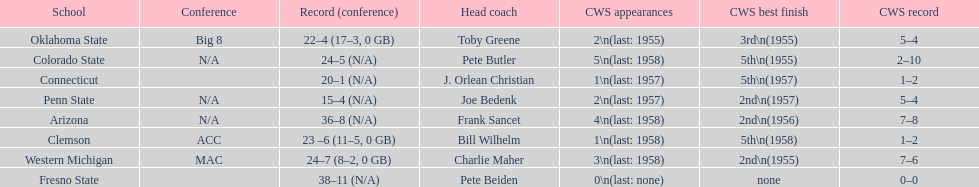Which teams played in the 1959 ncaa university division baseball tournament? Arizona, Clemson, Colorado State, Connecticut, Fresno State, Oklahoma State, Penn State, Western Michigan. Which was the only one to win less than 20 games? Penn State. 